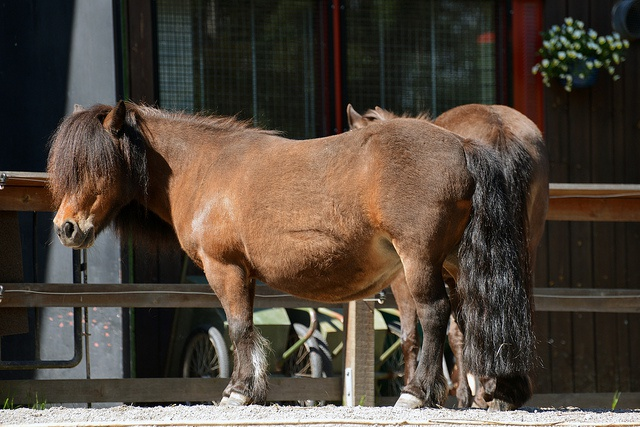Describe the objects in this image and their specific colors. I can see horse in black, gray, and tan tones, horse in black, gray, and maroon tones, and potted plant in black, gray, and darkgreen tones in this image. 